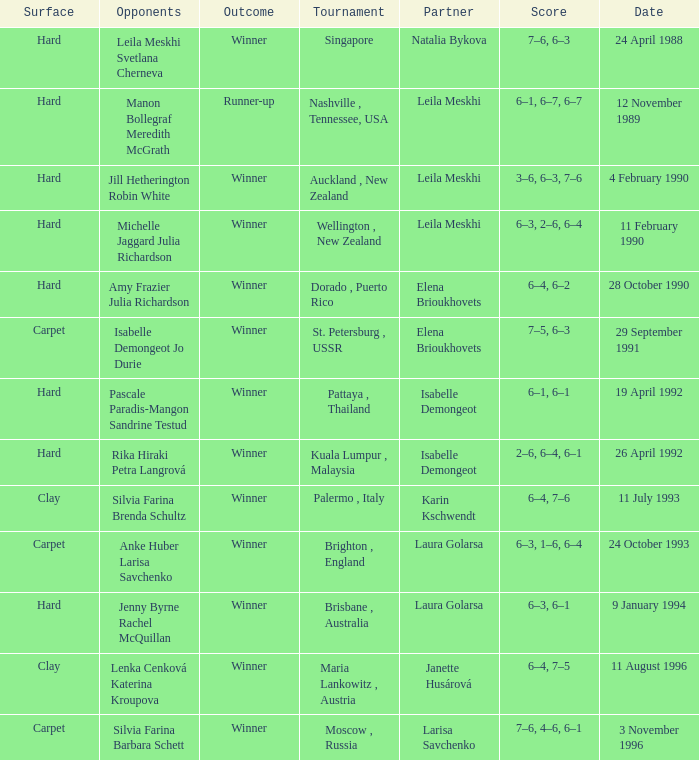Who was the teammate in a match that had a score of 6-4, 6-2 on a hard court? Elena Brioukhovets. Write the full table. {'header': ['Surface', 'Opponents', 'Outcome', 'Tournament', 'Partner', 'Score', 'Date'], 'rows': [['Hard', 'Leila Meskhi Svetlana Cherneva', 'Winner', 'Singapore', 'Natalia Bykova', '7–6, 6–3', '24 April 1988'], ['Hard', 'Manon Bollegraf Meredith McGrath', 'Runner-up', 'Nashville , Tennessee, USA', 'Leila Meskhi', '6–1, 6–7, 6–7', '12 November 1989'], ['Hard', 'Jill Hetherington Robin White', 'Winner', 'Auckland , New Zealand', 'Leila Meskhi', '3–6, 6–3, 7–6', '4 February 1990'], ['Hard', 'Michelle Jaggard Julia Richardson', 'Winner', 'Wellington , New Zealand', 'Leila Meskhi', '6–3, 2–6, 6–4', '11 February 1990'], ['Hard', 'Amy Frazier Julia Richardson', 'Winner', 'Dorado , Puerto Rico', 'Elena Brioukhovets', '6–4, 6–2', '28 October 1990'], ['Carpet', 'Isabelle Demongeot Jo Durie', 'Winner', 'St. Petersburg , USSR', 'Elena Brioukhovets', '7–5, 6–3', '29 September 1991'], ['Hard', 'Pascale Paradis-Mangon Sandrine Testud', 'Winner', 'Pattaya , Thailand', 'Isabelle Demongeot', '6–1, 6–1', '19 April 1992'], ['Hard', 'Rika Hiraki Petra Langrová', 'Winner', 'Kuala Lumpur , Malaysia', 'Isabelle Demongeot', '2–6, 6–4, 6–1', '26 April 1992'], ['Clay', 'Silvia Farina Brenda Schultz', 'Winner', 'Palermo , Italy', 'Karin Kschwendt', '6–4, 7–6', '11 July 1993'], ['Carpet', 'Anke Huber Larisa Savchenko', 'Winner', 'Brighton , England', 'Laura Golarsa', '6–3, 1–6, 6–4', '24 October 1993'], ['Hard', 'Jenny Byrne Rachel McQuillan', 'Winner', 'Brisbane , Australia', 'Laura Golarsa', '6–3, 6–1', '9 January 1994'], ['Clay', 'Lenka Cenková Katerina Kroupova', 'Winner', 'Maria Lankowitz , Austria', 'Janette Husárová', '6–4, 7–5', '11 August 1996'], ['Carpet', 'Silvia Farina Barbara Schett', 'Winner', 'Moscow , Russia', 'Larisa Savchenko', '7–6, 4–6, 6–1', '3 November 1996']]} 